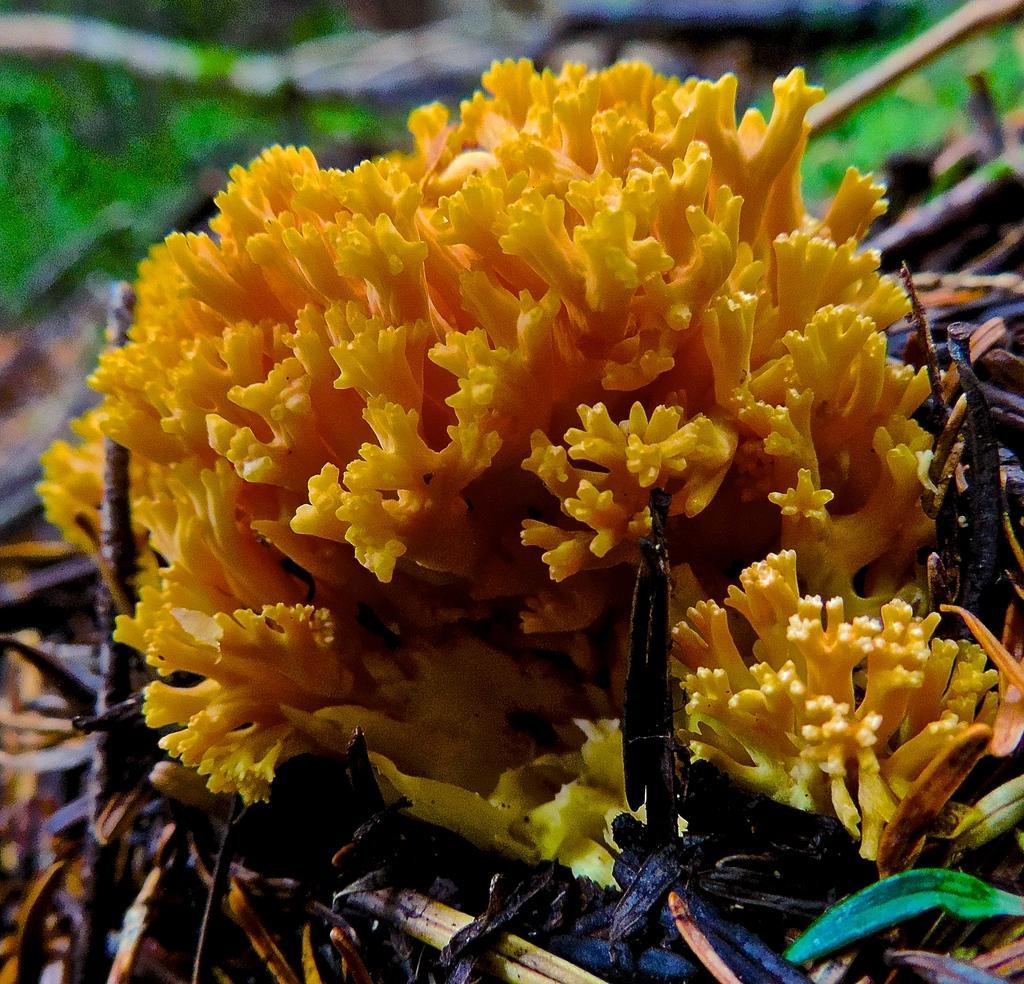Can you describe this image briefly? In this picture we can see a flower and leaves and in the background we can see it is blurry. 